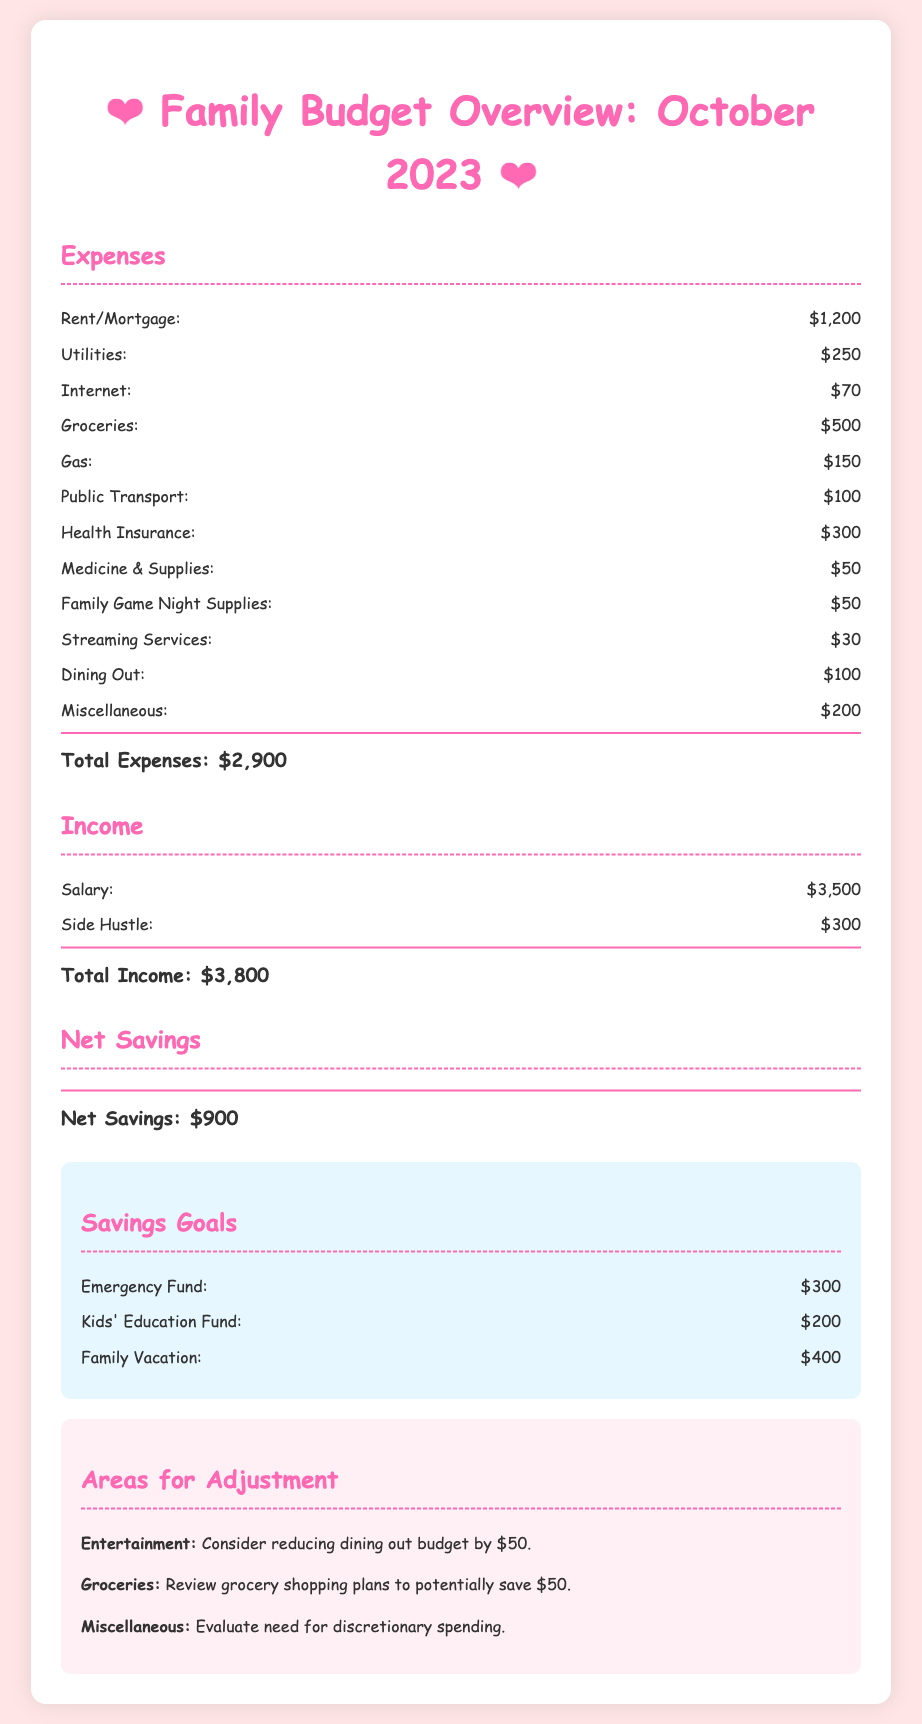What is the total expenses for October 2023? The total expenses section summarizes all expenses listed in the document, which adds up to $2,900.
Answer: $2,900 What is the total income for October 2023? The total income is calculated by adding the salary and side hustle earnings, which totals $3,800.
Answer: $3,800 What is the net savings for October 2023? The net savings is shown as the difference between total income and total expenses, which is $900.
Answer: $900 How much is allocated for the emergency fund? The savings goals section specifies the amount set for the emergency fund, which is $300.
Answer: $300 What area is suggested for adjustment regarding dining out? The document suggests reducing the dining out budget by $50 as an area for adjustment.
Answer: $50 How much is the budget for groceries in October 2023? The grocery budget is listed under expenses in the document, which is $500.
Answer: $500 What is the total amount set for family vacation savings? The document lists the family vacation savings goal as $400 under the savings goals section.
Answer: $400 Which expense category has a budget of $100? The document lists both dining out and public transport as having budgets of $100.
Answer: $100 What color is used for the header of the budget overview? The header color in the document is specified to be pink (#ff69b4).
Answer: Pink 